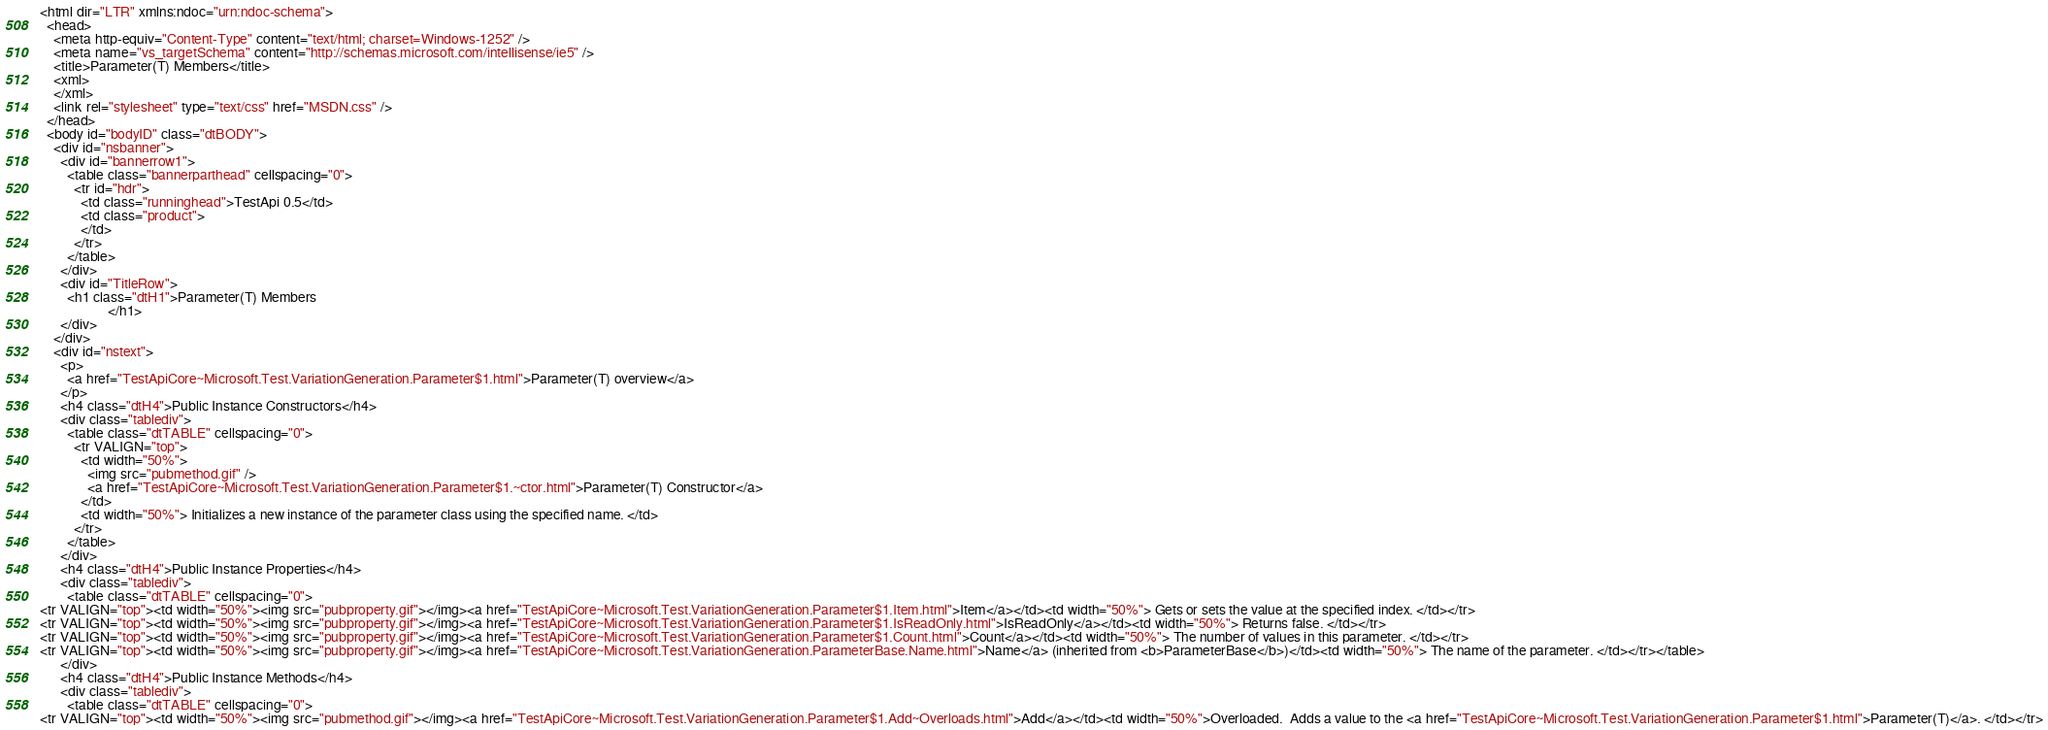Convert code to text. <code><loc_0><loc_0><loc_500><loc_500><_HTML_><html dir="LTR" xmlns:ndoc="urn:ndoc-schema">
  <head>
    <meta http-equiv="Content-Type" content="text/html; charset=Windows-1252" />
    <meta name="vs_targetSchema" content="http://schemas.microsoft.com/intellisense/ie5" />
    <title>Parameter(T) Members</title>
    <xml>
    </xml>
    <link rel="stylesheet" type="text/css" href="MSDN.css" />
  </head>
  <body id="bodyID" class="dtBODY">
    <div id="nsbanner">
      <div id="bannerrow1">
        <table class="bannerparthead" cellspacing="0">
          <tr id="hdr">
            <td class="runninghead">TestApi 0.5</td>
            <td class="product">
            </td>
          </tr>
        </table>
      </div>
      <div id="TitleRow">
        <h1 class="dtH1">Parameter(T) Members
					</h1>
      </div>
    </div>
    <div id="nstext">
      <p>
        <a href="TestApiCore~Microsoft.Test.VariationGeneration.Parameter$1.html">Parameter(T) overview</a>
      </p>
      <h4 class="dtH4">Public Instance Constructors</h4>
      <div class="tablediv">
        <table class="dtTABLE" cellspacing="0">
          <tr VALIGN="top">
            <td width="50%">
              <img src="pubmethod.gif" />
              <a href="TestApiCore~Microsoft.Test.VariationGeneration.Parameter$1.~ctor.html">Parameter(T) Constructor</a>
            </td>
            <td width="50%"> Initializes a new instance of the parameter class using the specified name. </td>
          </tr>
        </table>
      </div>
      <h4 class="dtH4">Public Instance Properties</h4>
      <div class="tablediv">
        <table class="dtTABLE" cellspacing="0">
<tr VALIGN="top"><td width="50%"><img src="pubproperty.gif"></img><a href="TestApiCore~Microsoft.Test.VariationGeneration.Parameter$1.Item.html">Item</a></td><td width="50%"> Gets or sets the value at the specified index. </td></tr>
<tr VALIGN="top"><td width="50%"><img src="pubproperty.gif"></img><a href="TestApiCore~Microsoft.Test.VariationGeneration.Parameter$1.IsReadOnly.html">IsReadOnly</a></td><td width="50%"> Returns false. </td></tr>
<tr VALIGN="top"><td width="50%"><img src="pubproperty.gif"></img><a href="TestApiCore~Microsoft.Test.VariationGeneration.Parameter$1.Count.html">Count</a></td><td width="50%"> The number of values in this parameter. </td></tr>
<tr VALIGN="top"><td width="50%"><img src="pubproperty.gif"></img><a href="TestApiCore~Microsoft.Test.VariationGeneration.ParameterBase.Name.html">Name</a> (inherited from <b>ParameterBase</b>)</td><td width="50%"> The name of the parameter. </td></tr></table>
      </div>
      <h4 class="dtH4">Public Instance Methods</h4>
      <div class="tablediv">
        <table class="dtTABLE" cellspacing="0">
<tr VALIGN="top"><td width="50%"><img src="pubmethod.gif"></img><a href="TestApiCore~Microsoft.Test.VariationGeneration.Parameter$1.Add~Overloads.html">Add</a></td><td width="50%">Overloaded.  Adds a value to the <a href="TestApiCore~Microsoft.Test.VariationGeneration.Parameter$1.html">Parameter(T)</a>. </td></tr></code> 